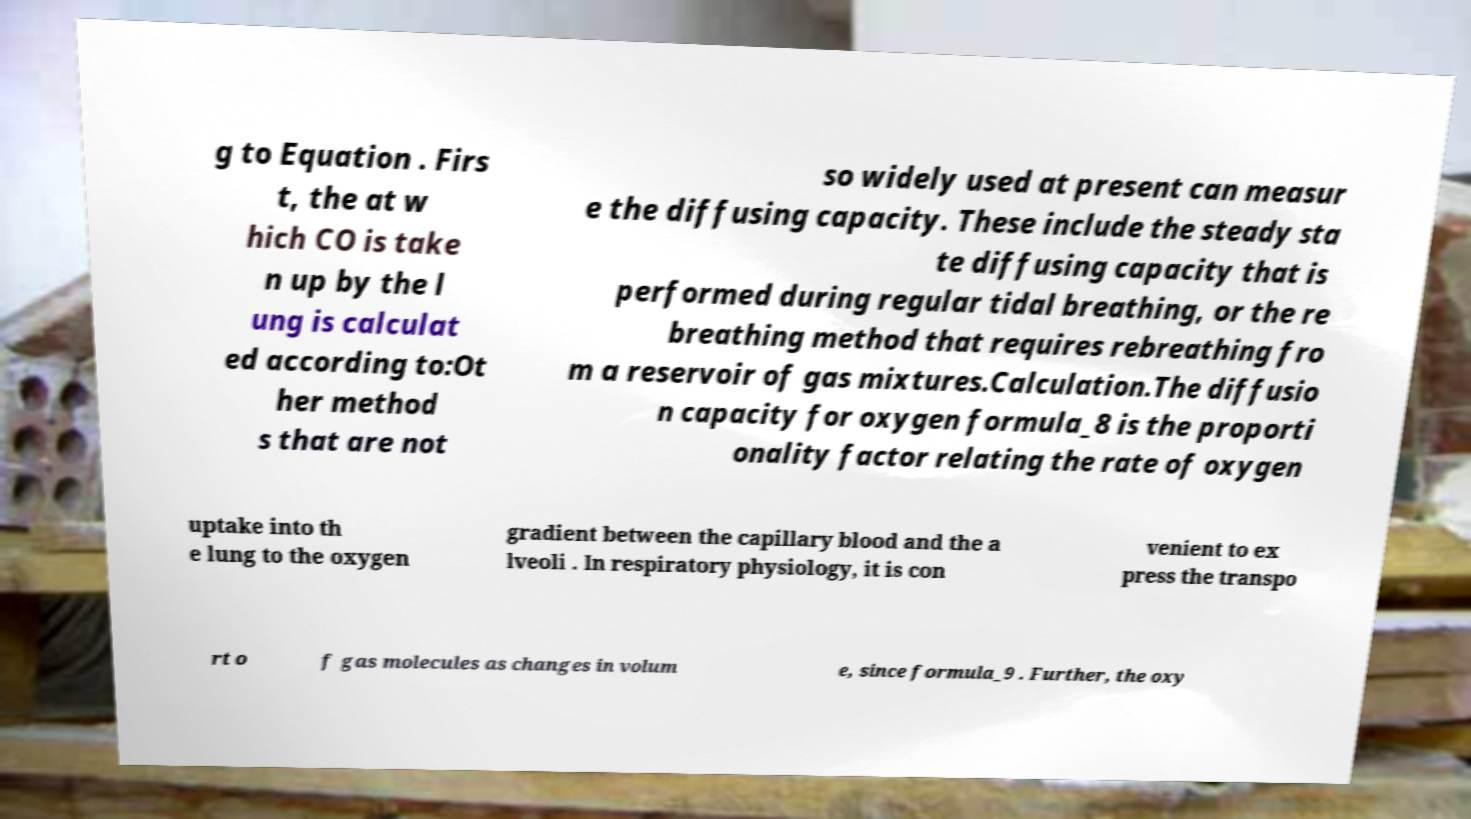For documentation purposes, I need the text within this image transcribed. Could you provide that? g to Equation . Firs t, the at w hich CO is take n up by the l ung is calculat ed according to:Ot her method s that are not so widely used at present can measur e the diffusing capacity. These include the steady sta te diffusing capacity that is performed during regular tidal breathing, or the re breathing method that requires rebreathing fro m a reservoir of gas mixtures.Calculation.The diffusio n capacity for oxygen formula_8 is the proporti onality factor relating the rate of oxygen uptake into th e lung to the oxygen gradient between the capillary blood and the a lveoli . In respiratory physiology, it is con venient to ex press the transpo rt o f gas molecules as changes in volum e, since formula_9 . Further, the oxy 